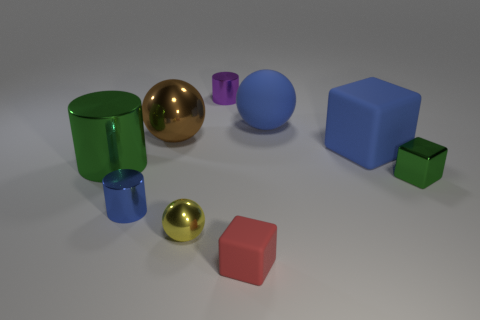Subtract all tiny cylinders. How many cylinders are left? 1 Subtract 1 cylinders. How many cylinders are left? 2 Subtract all spheres. How many objects are left? 6 Add 1 blue shiny objects. How many objects exist? 10 Add 5 blue matte blocks. How many blue matte blocks exist? 6 Subtract 0 yellow blocks. How many objects are left? 9 Subtract all matte cubes. Subtract all large green things. How many objects are left? 6 Add 5 small metal cubes. How many small metal cubes are left? 6 